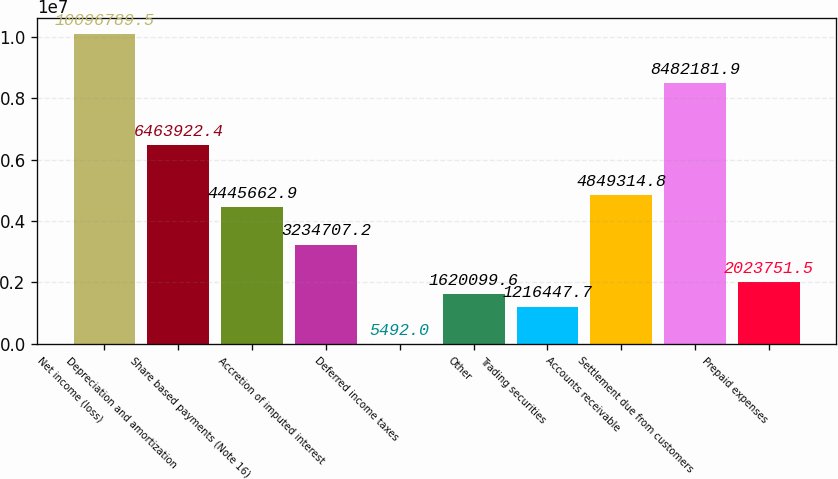<chart> <loc_0><loc_0><loc_500><loc_500><bar_chart><fcel>Net income (loss)<fcel>Depreciation and amortization<fcel>Share based payments (Note 16)<fcel>Accretion of imputed interest<fcel>Deferred income taxes<fcel>Other<fcel>Trading securities<fcel>Accounts receivable<fcel>Settlement due from customers<fcel>Prepaid expenses<nl><fcel>1.00968e+07<fcel>6.46392e+06<fcel>4.44566e+06<fcel>3.23471e+06<fcel>5492<fcel>1.6201e+06<fcel>1.21645e+06<fcel>4.84931e+06<fcel>8.48218e+06<fcel>2.02375e+06<nl></chart> 